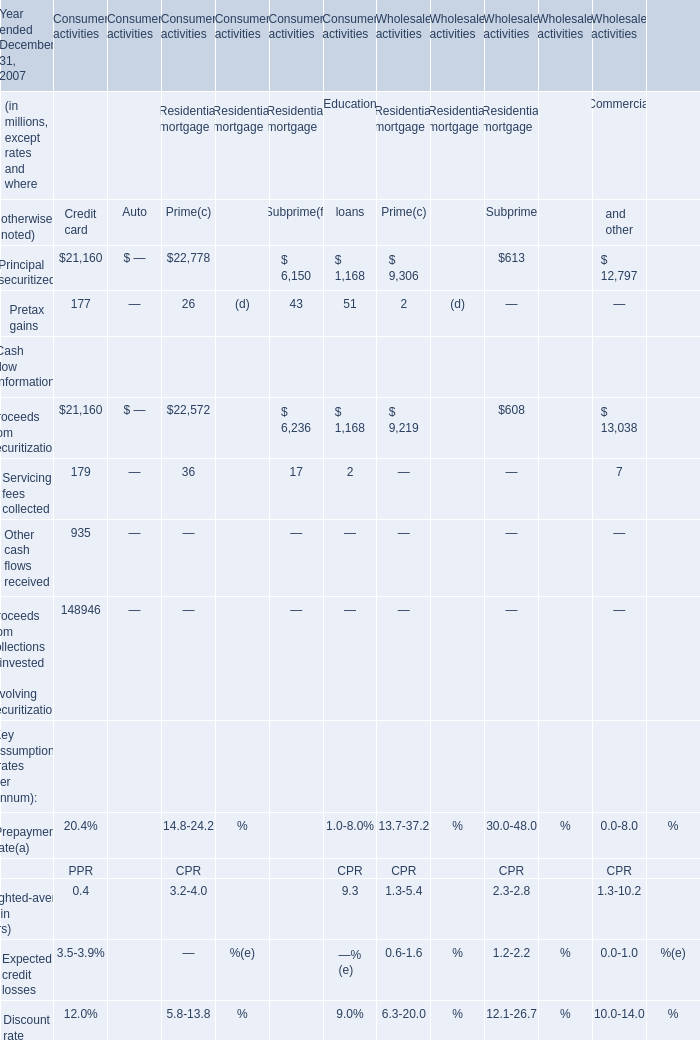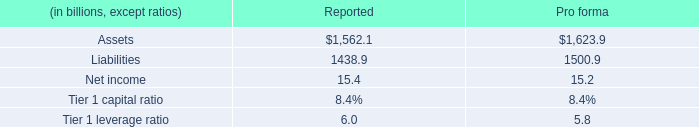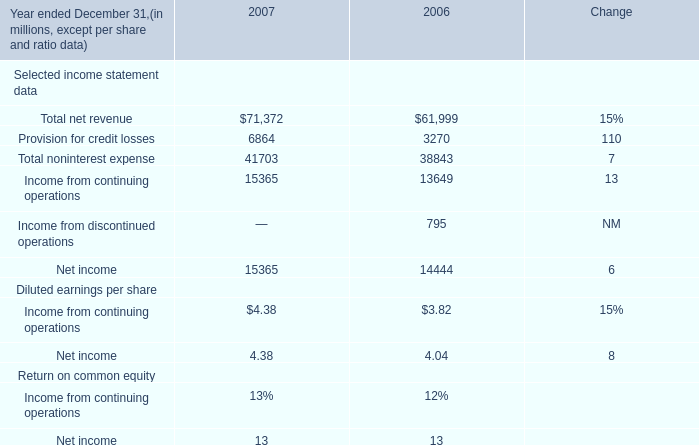What is the ratio of Proceeds from securitizations of Credit card in Table 0 to the Total noninterest expense in Table 2 in 2007? 
Computations: (21160 / 41703)
Answer: 0.5074. 